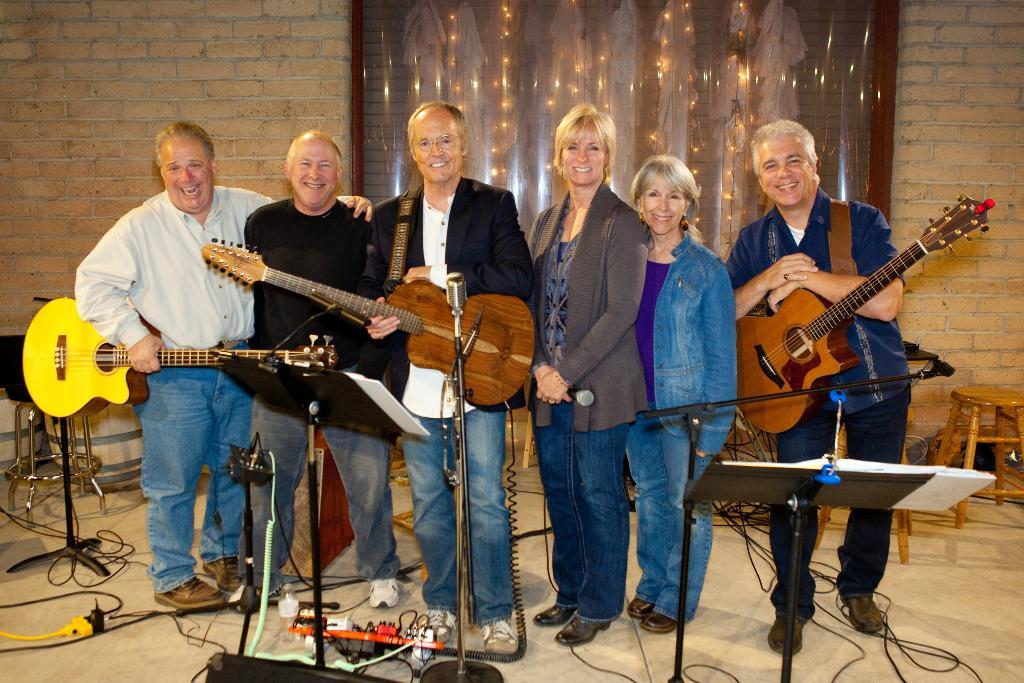What is happening in the center of the image? There is a group of persons in the center of the image. What are the persons doing? The persons are standing and holding guitars. What is the mood of the persons in the image? The persons are smiling. What equipment is present in front of the group? There is a microphone in front of the group. What can be seen in the background of the image? There is a wall in the background, along with stools and a chair. What type of cabbage is being used as a prop in the image? There is no cabbage present in the image. What organization is responsible for the event depicted in the image? The image does not provide any information about an event or an organization. 